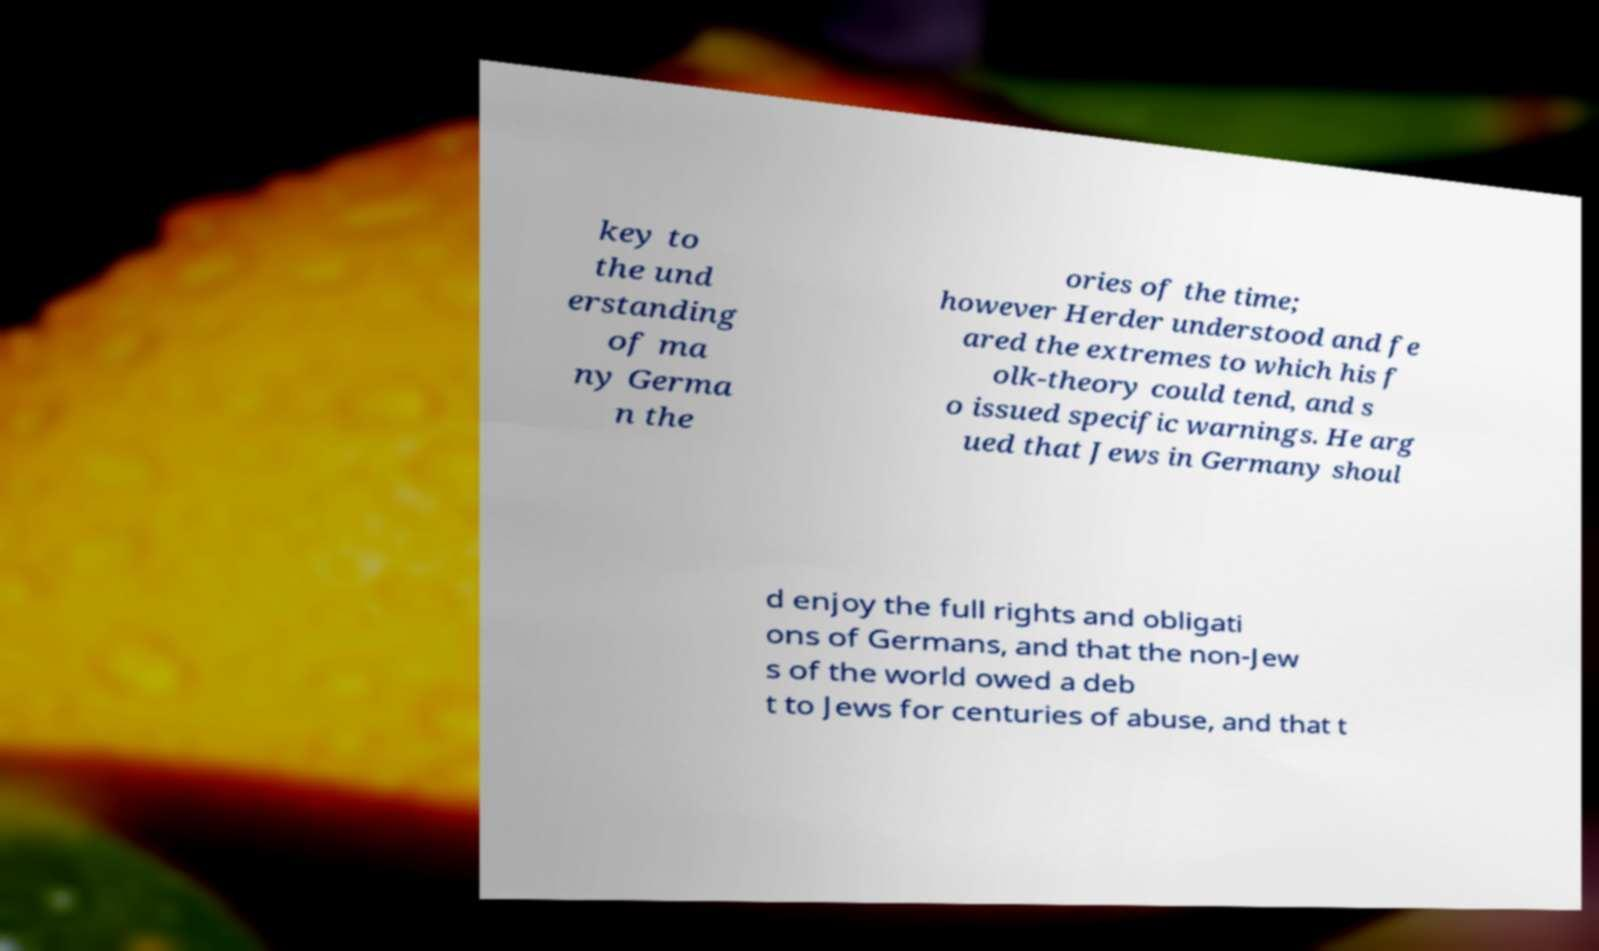There's text embedded in this image that I need extracted. Can you transcribe it verbatim? key to the und erstanding of ma ny Germa n the ories of the time; however Herder understood and fe ared the extremes to which his f olk-theory could tend, and s o issued specific warnings. He arg ued that Jews in Germany shoul d enjoy the full rights and obligati ons of Germans, and that the non-Jew s of the world owed a deb t to Jews for centuries of abuse, and that t 